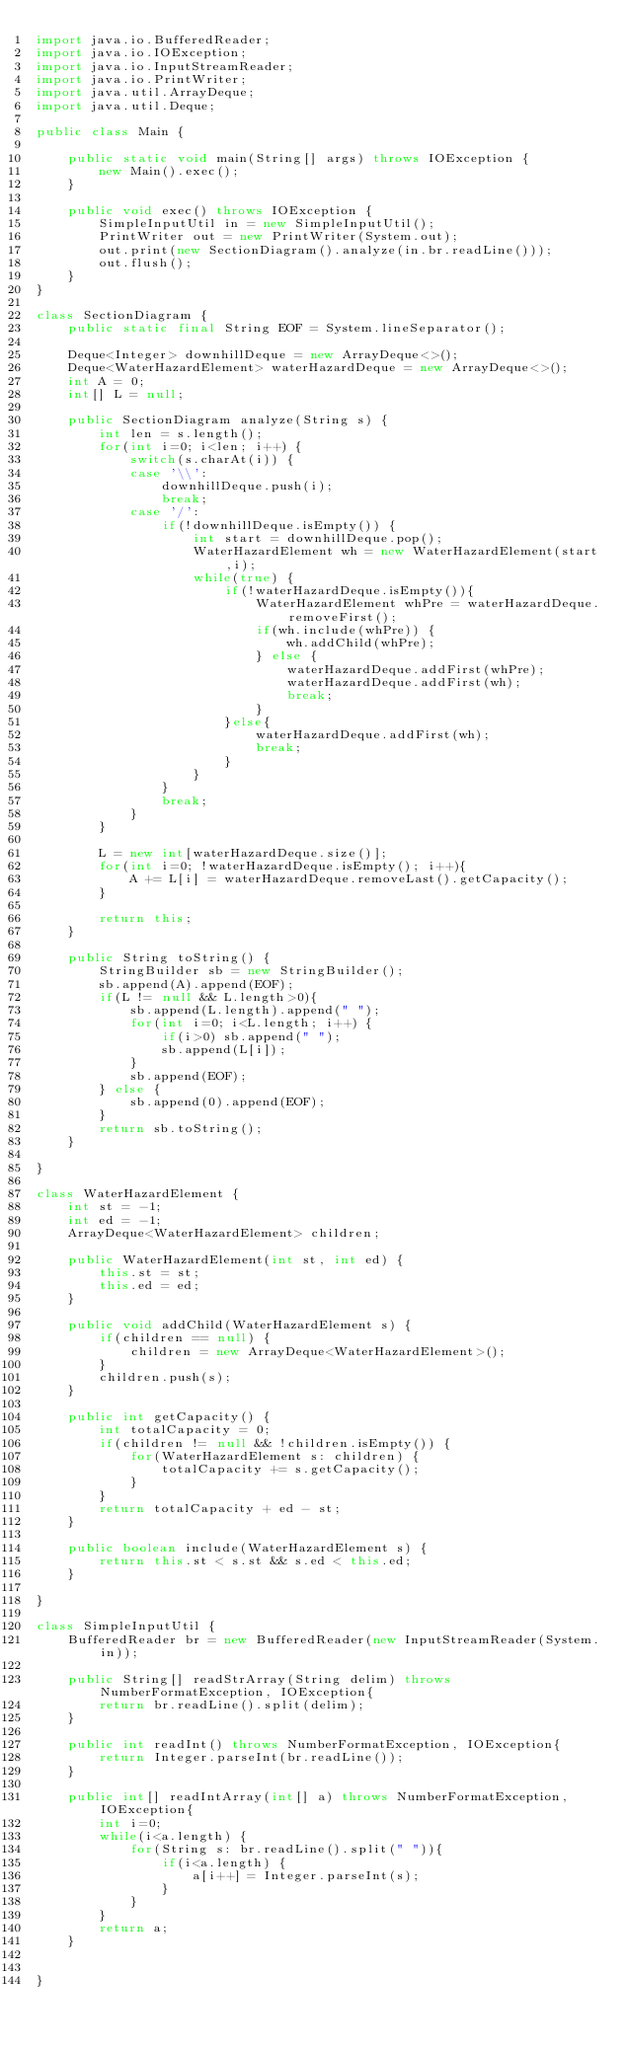Convert code to text. <code><loc_0><loc_0><loc_500><loc_500><_Java_>import java.io.BufferedReader;
import java.io.IOException;
import java.io.InputStreamReader;
import java.io.PrintWriter;
import java.util.ArrayDeque;
import java.util.Deque;
   
public class Main {
     
    public static void main(String[] args) throws IOException {
        new Main().exec();
    }
     
    public void exec() throws IOException {
        SimpleInputUtil in = new SimpleInputUtil();
        PrintWriter out = new PrintWriter(System.out);
        out.print(new SectionDiagram().analyze(in.br.readLine()));
        out.flush();
    }
}

class SectionDiagram {
	public static final String EOF = System.lineSeparator();

	Deque<Integer> downhillDeque = new ArrayDeque<>();
	Deque<WaterHazardElement> waterHazardDeque = new ArrayDeque<>();
	int A = 0;
	int[] L = null;
	
	public SectionDiagram analyze(String s) {
		int len = s.length();
		for(int i=0; i<len; i++) {
			switch(s.charAt(i)) {
			case '\\':
				downhillDeque.push(i);
				break;
			case '/':
				if(!downhillDeque.isEmpty()) {
					int start = downhillDeque.pop();
					WaterHazardElement wh = new WaterHazardElement(start,i);
					while(true) {
						if(!waterHazardDeque.isEmpty()){
							WaterHazardElement whPre = waterHazardDeque.removeFirst();
							if(wh.include(whPre)) {
								wh.addChild(whPre);
							} else {
								waterHazardDeque.addFirst(whPre);
								waterHazardDeque.addFirst(wh);
								break;
							}
						}else{
							waterHazardDeque.addFirst(wh);
							break;
						}
					}
				}
				break;
			}
		}
		
		L = new int[waterHazardDeque.size()];
		for(int i=0; !waterHazardDeque.isEmpty(); i++){
			A += L[i] = waterHazardDeque.removeLast().getCapacity();
		}

		return this;
	}
	
	public String toString() {
		StringBuilder sb = new StringBuilder();
		sb.append(A).append(EOF);
		if(L != null && L.length>0){
			sb.append(L.length).append(" ");
			for(int i=0; i<L.length; i++) {
				if(i>0) sb.append(" ");
				sb.append(L[i]);
			}
			sb.append(EOF);
		} else {
			sb.append(0).append(EOF);
		}
		return sb.toString();
	}
	
}

class WaterHazardElement {
	int st = -1;
	int ed = -1;
	ArrayDeque<WaterHazardElement> children;
	
	public WaterHazardElement(int st, int ed) {
		this.st = st;
		this.ed = ed;
	}
	
	public void addChild(WaterHazardElement s) {
		if(children == null) {
			children = new ArrayDeque<WaterHazardElement>();
		}
		children.push(s);
	}
	
	public int getCapacity() {
		int totalCapacity = 0;
		if(children != null && !children.isEmpty()) {
			for(WaterHazardElement s: children) {
				totalCapacity += s.getCapacity();
			}
		}
		return totalCapacity + ed - st;
	}
	
	public boolean include(WaterHazardElement s) {
		return this.st < s.st && s.ed < this.ed;
	}
	
}
 
class SimpleInputUtil {
    BufferedReader br = new BufferedReader(new InputStreamReader(System.in));
 
    public String[] readStrArray(String delim) throws NumberFormatException, IOException{
        return br.readLine().split(delim);
    }
     
    public int readInt() throws NumberFormatException, IOException{
        return Integer.parseInt(br.readLine());
    }
     
    public int[] readIntArray(int[] a) throws NumberFormatException, IOException{
        int i=0;
        while(i<a.length) {
            for(String s: br.readLine().split(" ")){
                if(i<a.length) {
                    a[i++] = Integer.parseInt(s);
                }
            }
        }
        return a;
    }
 
     
}</code> 